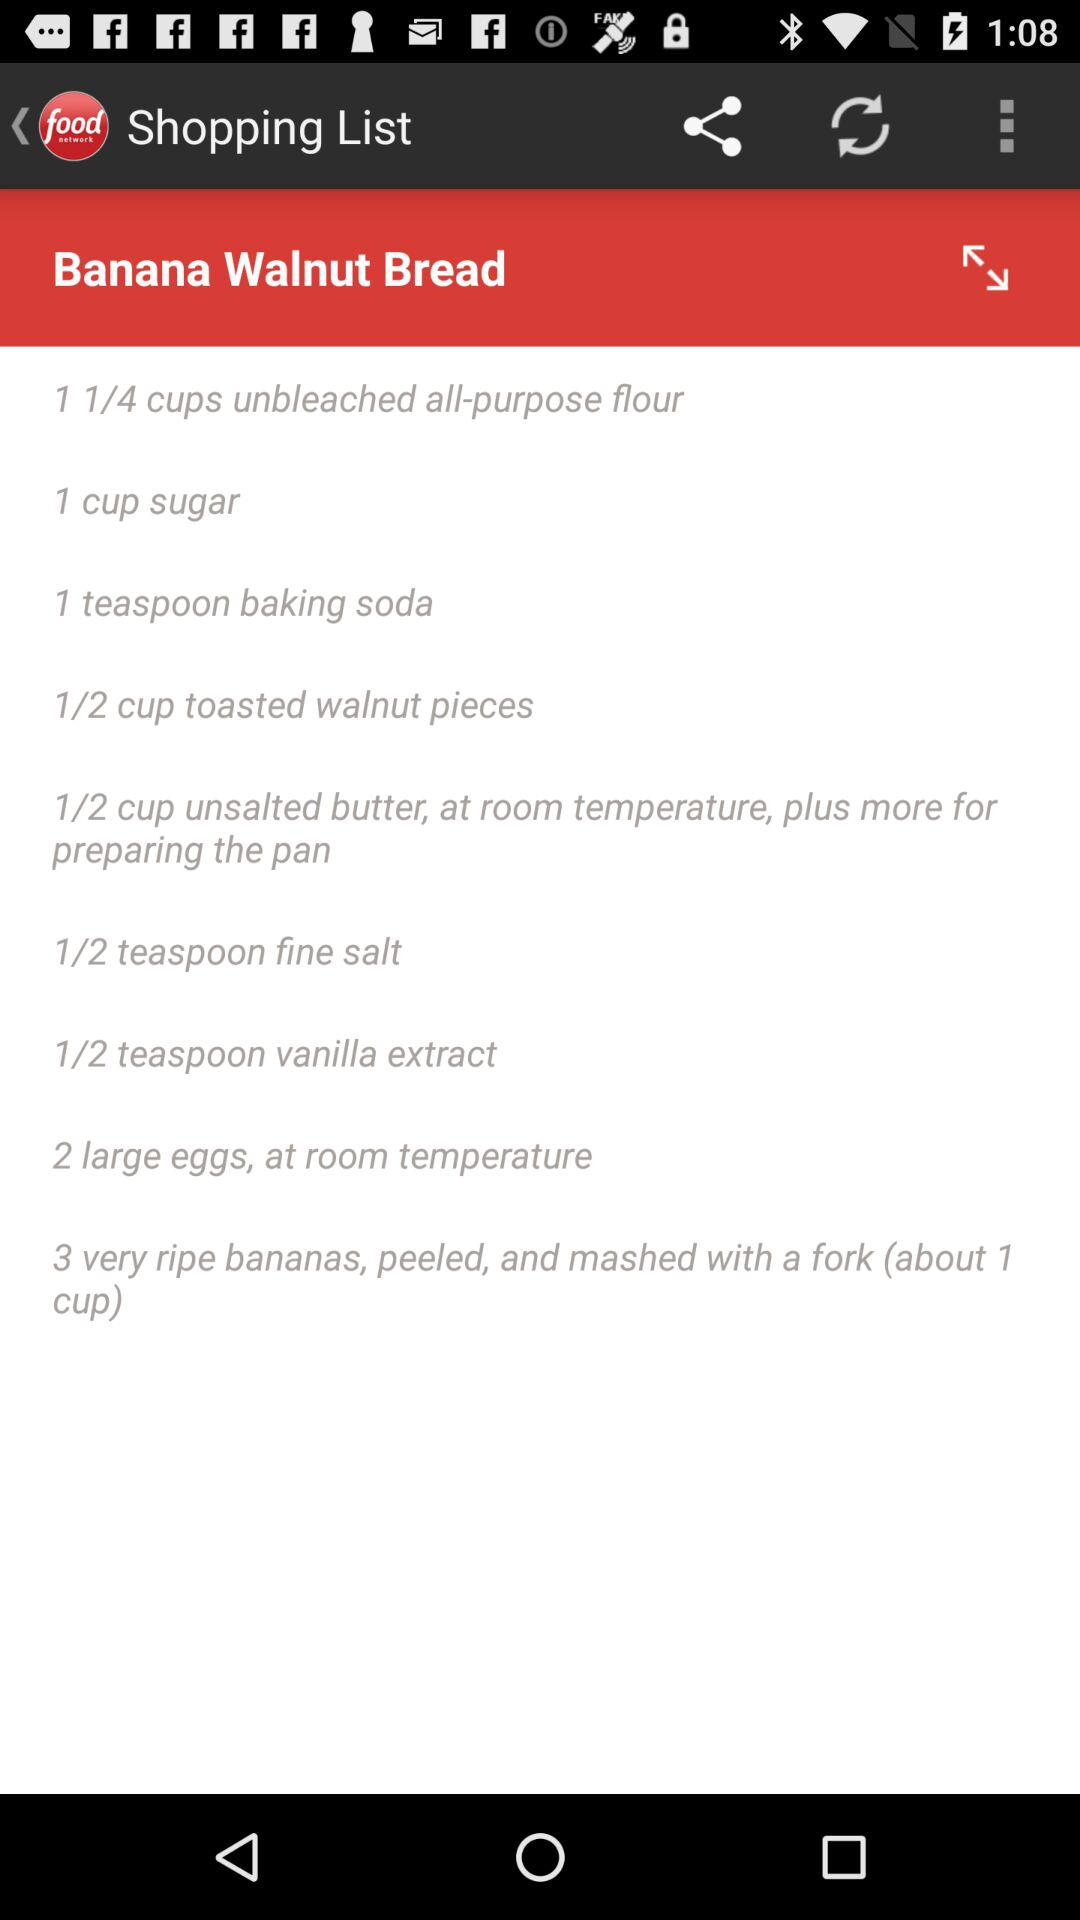How much sugar is required? The required amount of sugar is 1 cup. 